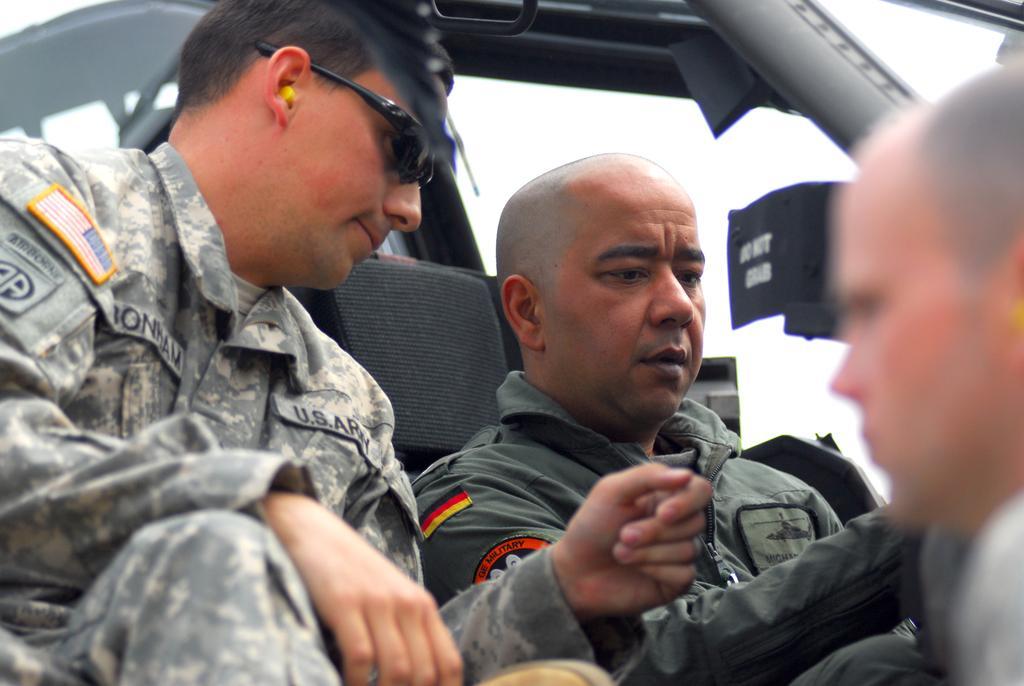Please provide a concise description of this image. In this picture there are two men in a vehicle wearing army uniforms. On the right there is a person's face, the face is blurred. 